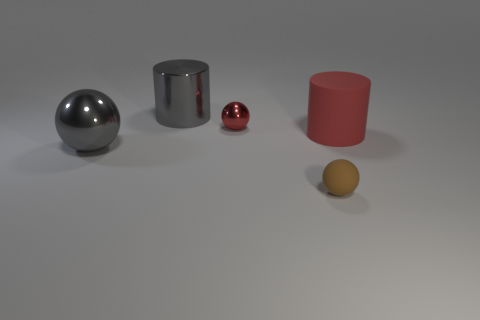What is the shape of the big gray object that is the same material as the gray ball?
Give a very brief answer. Cylinder. Is there a red matte thing on the left side of the metallic ball that is in front of the tiny red metallic object?
Your answer should be very brief. No. How big is the matte ball?
Your response must be concise. Small. What number of objects are either gray metal objects or yellow spheres?
Your answer should be very brief. 2. Do the small object that is in front of the tiny shiny thing and the red cylinder to the right of the big sphere have the same material?
Offer a terse response. Yes. There is a large cylinder that is made of the same material as the tiny red sphere; what color is it?
Provide a succinct answer. Gray. What number of brown objects have the same size as the red sphere?
Offer a terse response. 1. What number of other things are there of the same color as the matte ball?
Offer a terse response. 0. There is a large gray thing in front of the tiny metallic ball; does it have the same shape as the rubber thing that is in front of the large red matte cylinder?
Offer a very short reply. Yes. There is a matte object that is the same size as the gray metal cylinder; what shape is it?
Your answer should be very brief. Cylinder. 